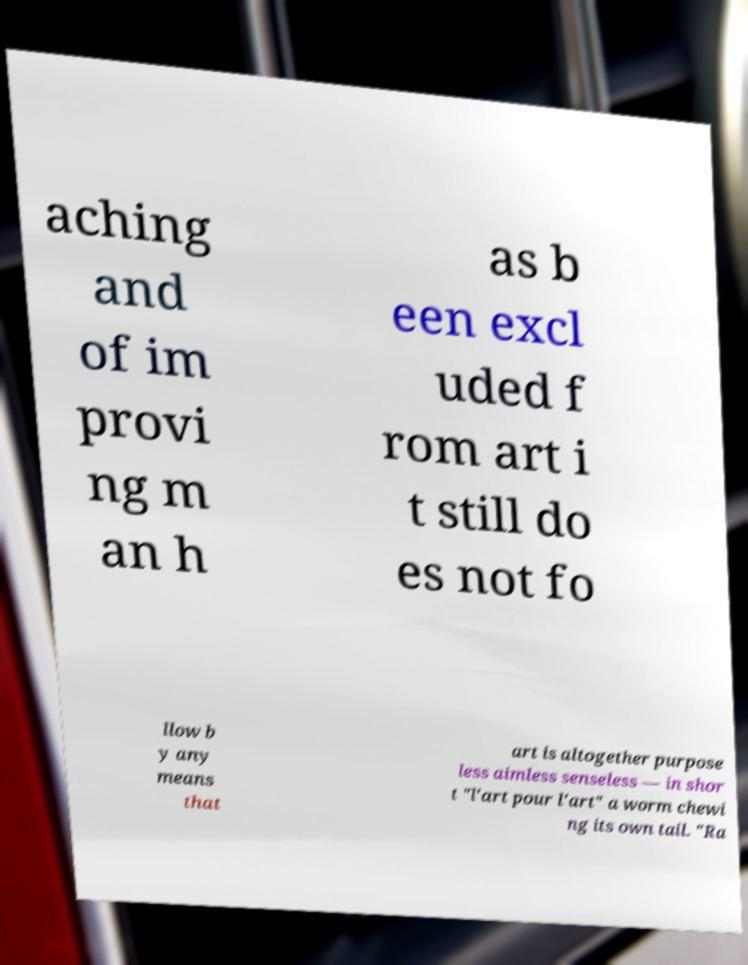Could you assist in decoding the text presented in this image and type it out clearly? aching and of im provi ng m an h as b een excl uded f rom art i t still do es not fo llow b y any means that art is altogether purpose less aimless senseless — in shor t "l'art pour l'art" a worm chewi ng its own tail. "Ra 